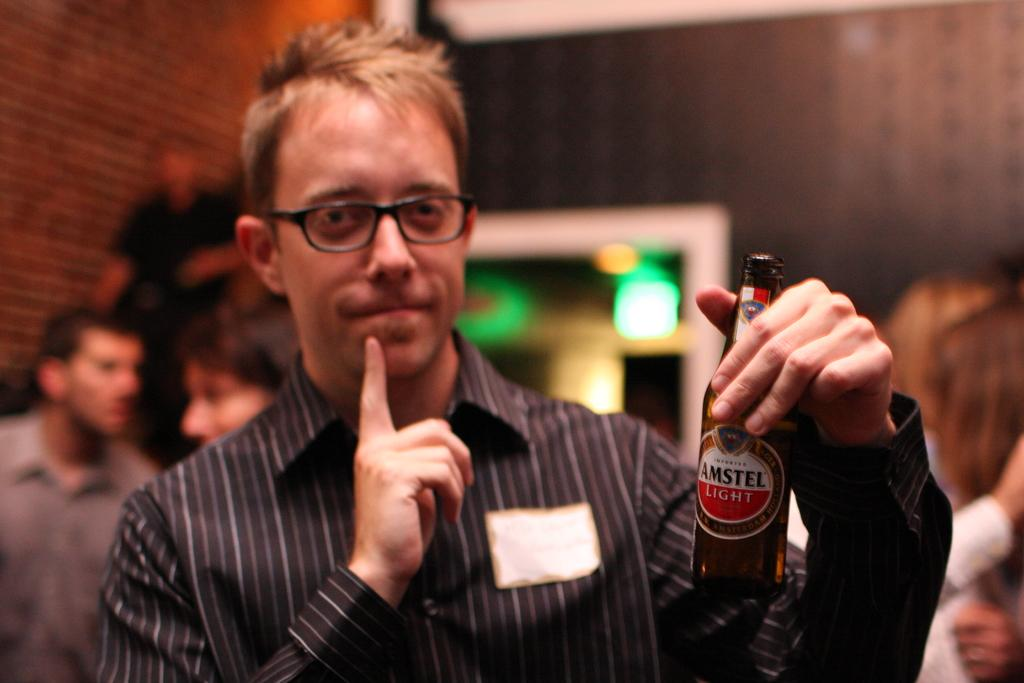What is the main subject of the image? There is a man in the image. What is the man doing in the image? The man is standing in the image. What is the man holding in his hand? The man is holding a wine bottle in his hand. Can you describe the background of the image? There are people standing in the background of the image. How would you describe the quality of the image? The image is blurry. What is the man's opinion on the current state of the economy in the image? There is no information about the man's opinion on the economy in the image. 